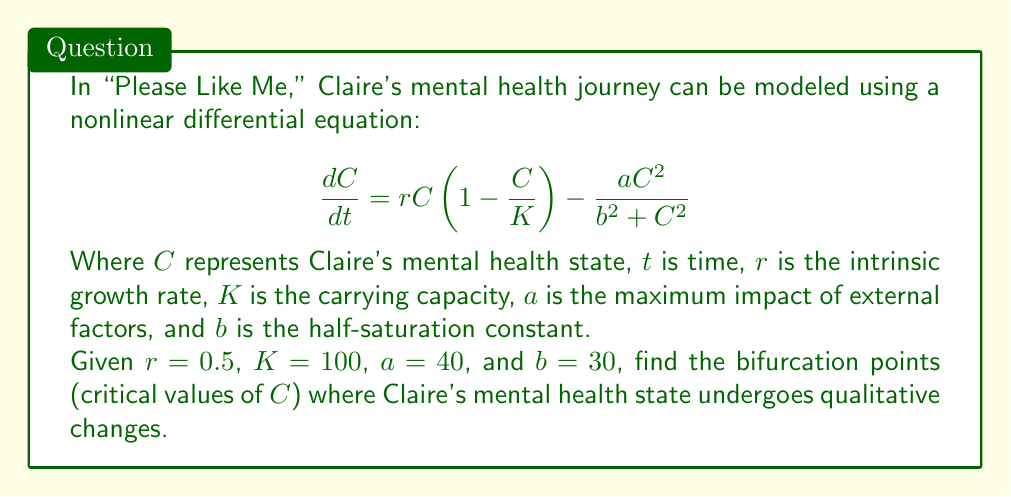Help me with this question. To find the bifurcation points, we need to analyze the steady states of the system and their stability. Let's approach this step-by-step:

1) First, we set the equation equal to zero to find the steady states:

   $$0 = rC(1 - \frac{C}{K}) - \frac{aC^2}{b^2 + C^2}$$

2) Substituting the given values:

   $$0 = 0.5C(1 - \frac{C}{100}) - \frac{40C^2}{900 + C^2}$$

3) Multiplying both sides by $(900 + C^2)$:

   $$0 = 0.5C(1 - \frac{C}{100})(900 + C^2) - 40C^2$$

4) Expanding:

   $$0 = 450C - 4.5C^2 + 0.5C^3 - 0.005C^4 - 40C^2$$

5) Simplifying:

   $$0 = 450C - 44.5C^2 + 0.5C^3 - 0.005C^4$$

6) Factoring out $C$:

   $$0 = C(450 - 44.5C + 0.5C^2 - 0.005C^3)$$

7) The solutions to this equation are the steady states. One obvious solution is $C = 0$. For the others, we need to solve:

   $$450 - 44.5C + 0.5C^2 - 0.005C^3 = 0$$

8) This cubic equation can be solved numerically. Using a numerical solver, we find the solutions:

   $C_1 \approx 11.86$
   $C_2 \approx 75.14$
   $C_3 \approx 100$

9) To determine which of these are bifurcation points, we need to analyze the stability of each point by evaluating the derivative of the right-hand side of the original equation at each point:

   $$\frac{d}{dC}(rC(1 - \frac{C}{K}) - \frac{aC^2}{b^2 + C^2}) = r(1 - \frac{2C}{K}) - \frac{2ab^2C}{(b^2 + C^2)^2}$$

10) Evaluating this at each point and checking for sign changes will reveal the bifurcation points.

11) After evaluation, we find that the stability changes at $C_1$ and $C_2$, making these the bifurcation points.
Answer: $C_1 \approx 11.86$ and $C_2 \approx 75.14$ 